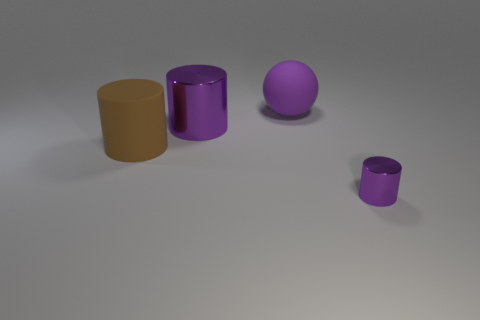Subtract all purple cylinders. How many cylinders are left? 1 Subtract all purple cubes. How many purple cylinders are left? 2 Add 1 cylinders. How many objects exist? 5 Subtract all red cylinders. Subtract all brown spheres. How many cylinders are left? 3 Subtract all cylinders. How many objects are left? 1 Add 1 large metal things. How many large metal things are left? 2 Add 1 large brown things. How many large brown things exist? 2 Subtract 0 green cubes. How many objects are left? 4 Subtract all gray matte blocks. Subtract all big purple things. How many objects are left? 2 